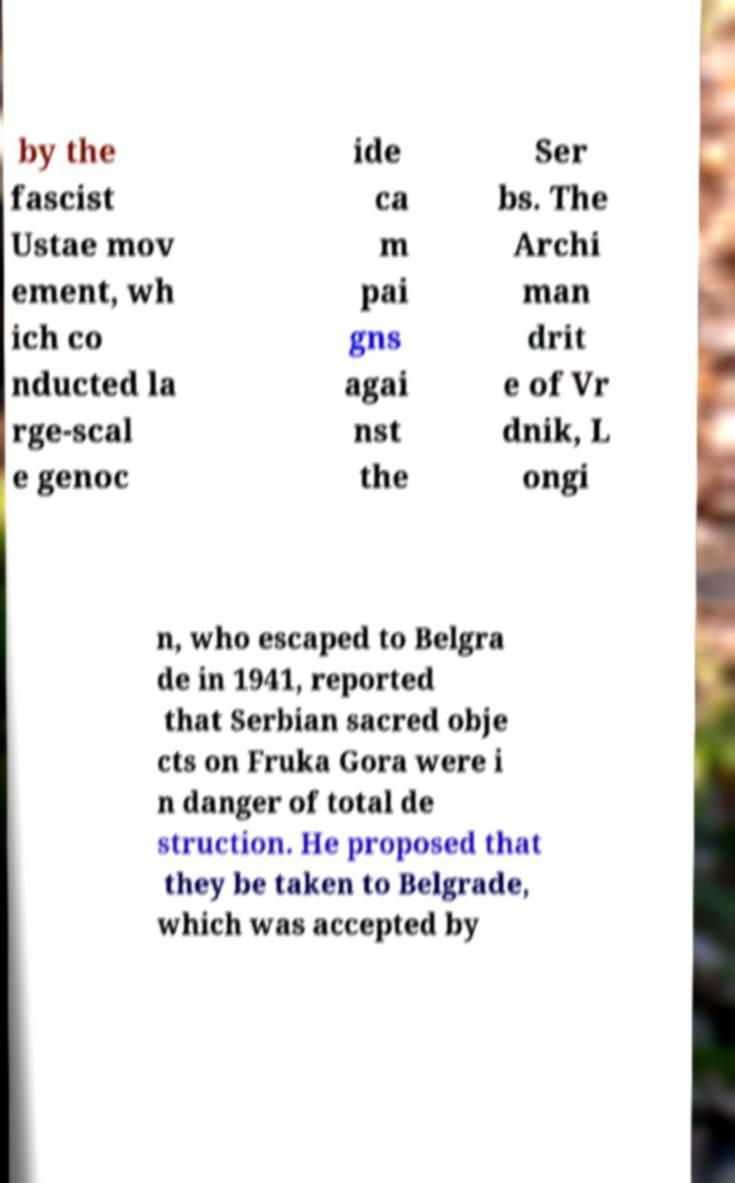I need the written content from this picture converted into text. Can you do that? by the fascist Ustae mov ement, wh ich co nducted la rge-scal e genoc ide ca m pai gns agai nst the Ser bs. The Archi man drit e of Vr dnik, L ongi n, who escaped to Belgra de in 1941, reported that Serbian sacred obje cts on Fruka Gora were i n danger of total de struction. He proposed that they be taken to Belgrade, which was accepted by 